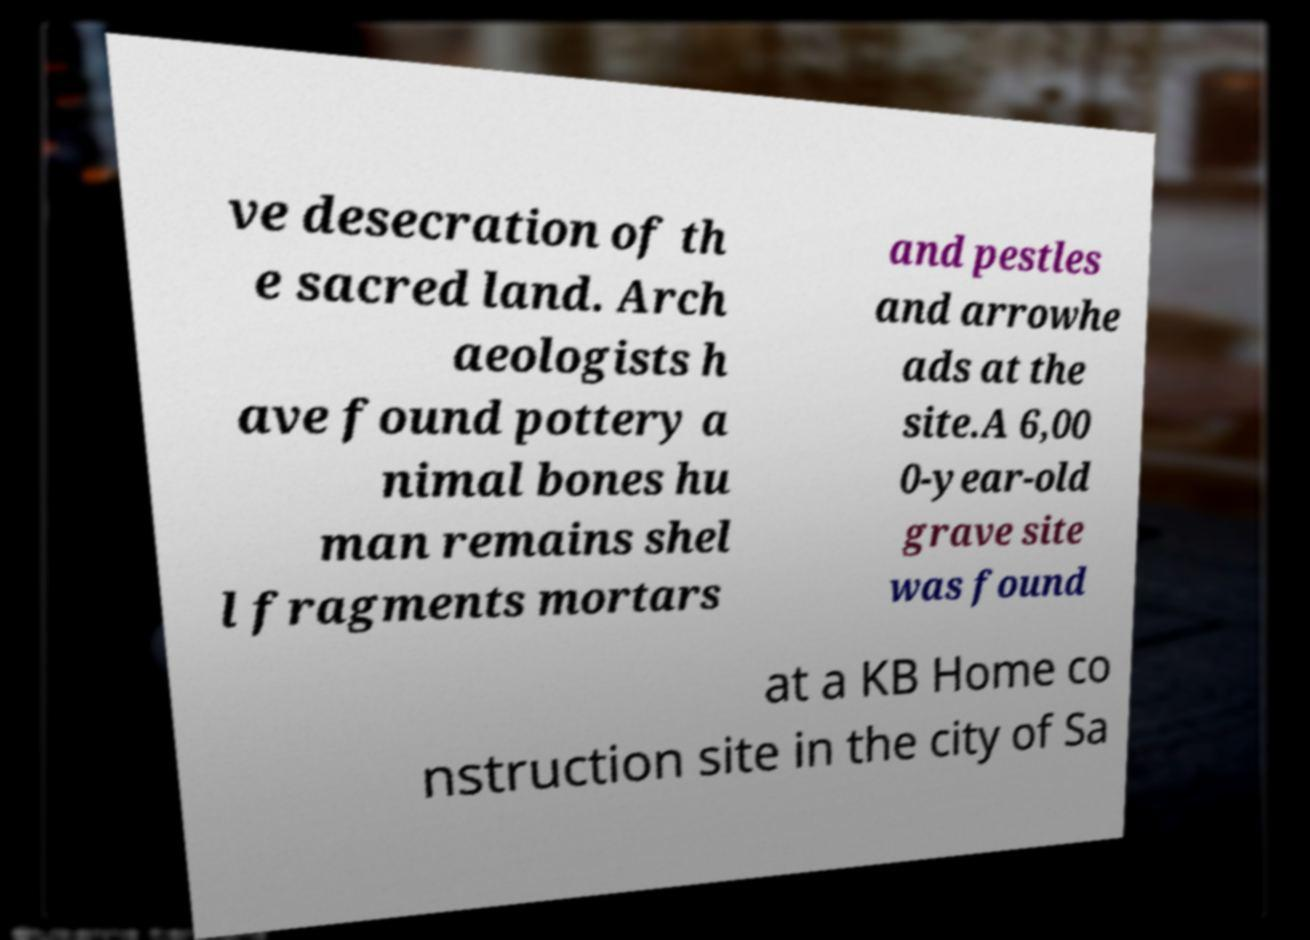There's text embedded in this image that I need extracted. Can you transcribe it verbatim? ve desecration of th e sacred land. Arch aeologists h ave found pottery a nimal bones hu man remains shel l fragments mortars and pestles and arrowhe ads at the site.A 6,00 0-year-old grave site was found at a KB Home co nstruction site in the city of Sa 